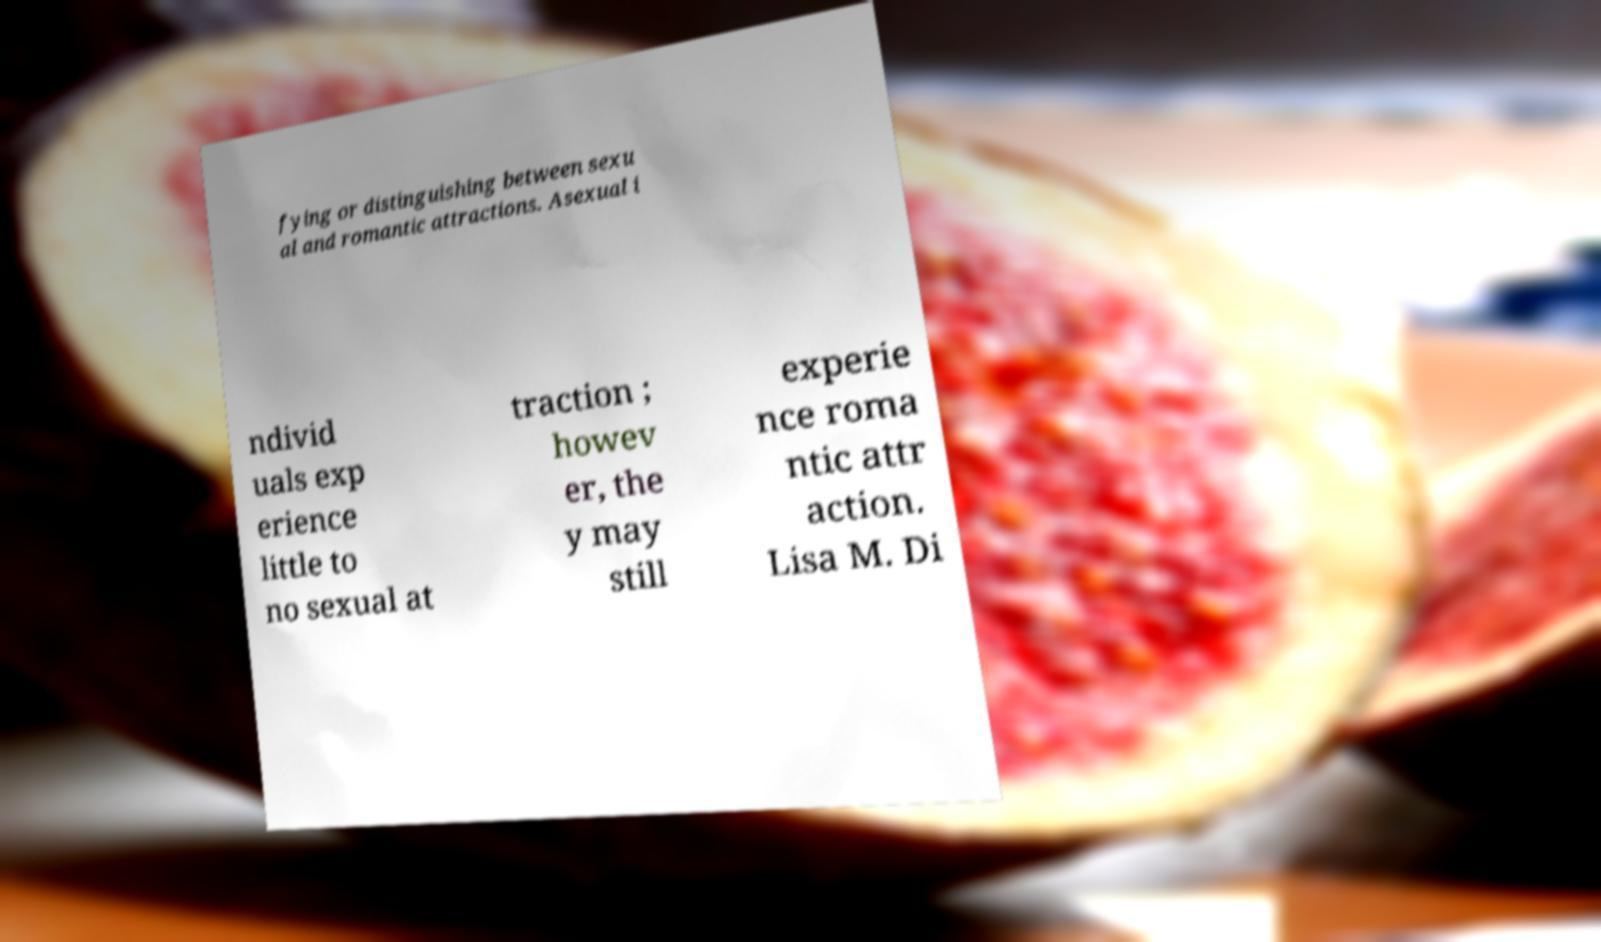Could you extract and type out the text from this image? fying or distinguishing between sexu al and romantic attractions. Asexual i ndivid uals exp erience little to no sexual at traction ; howev er, the y may still experie nce roma ntic attr action. Lisa M. Di 